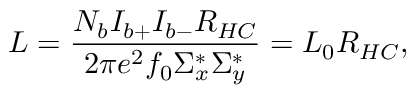Convert formula to latex. <formula><loc_0><loc_0><loc_500><loc_500>L = \frac { N _ { b } I _ { b + } I _ { b - } R _ { H C } } { 2 \pi e ^ { 2 } f _ { 0 } \Sigma _ { x } ^ { * } \Sigma _ { y } ^ { * } } = L _ { 0 } R _ { H C } ,</formula> 